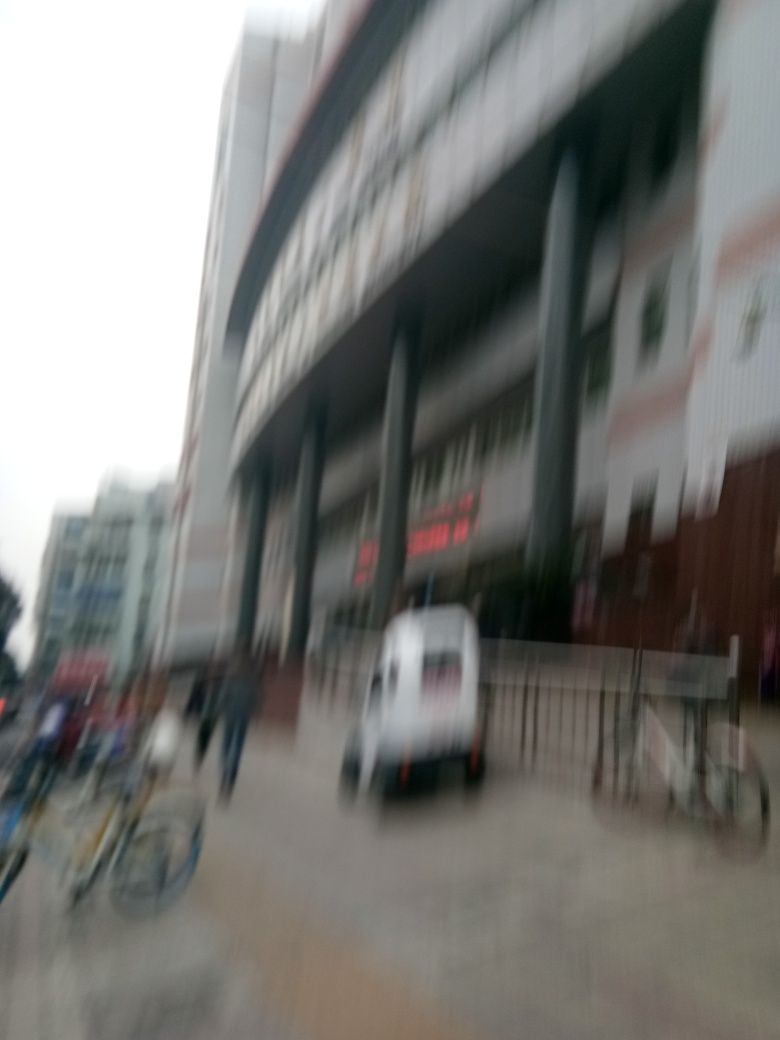How does the quality of the image affect its interpretation? The blurriness of the image obscures specific details, making it open to various interpretations. Key information like signs, the condition of the building, and people's expressions, which could offer context, are indistinguishable, leading to ambiguity about what's depicted. 